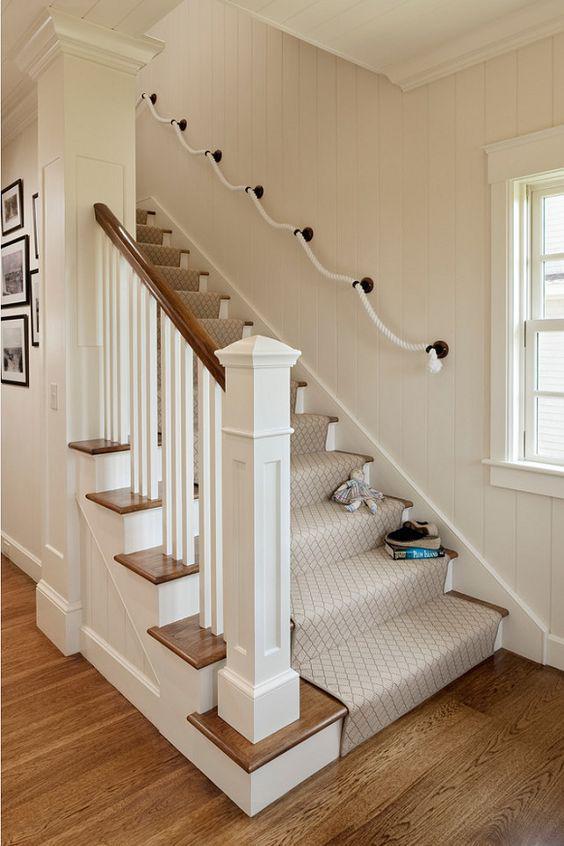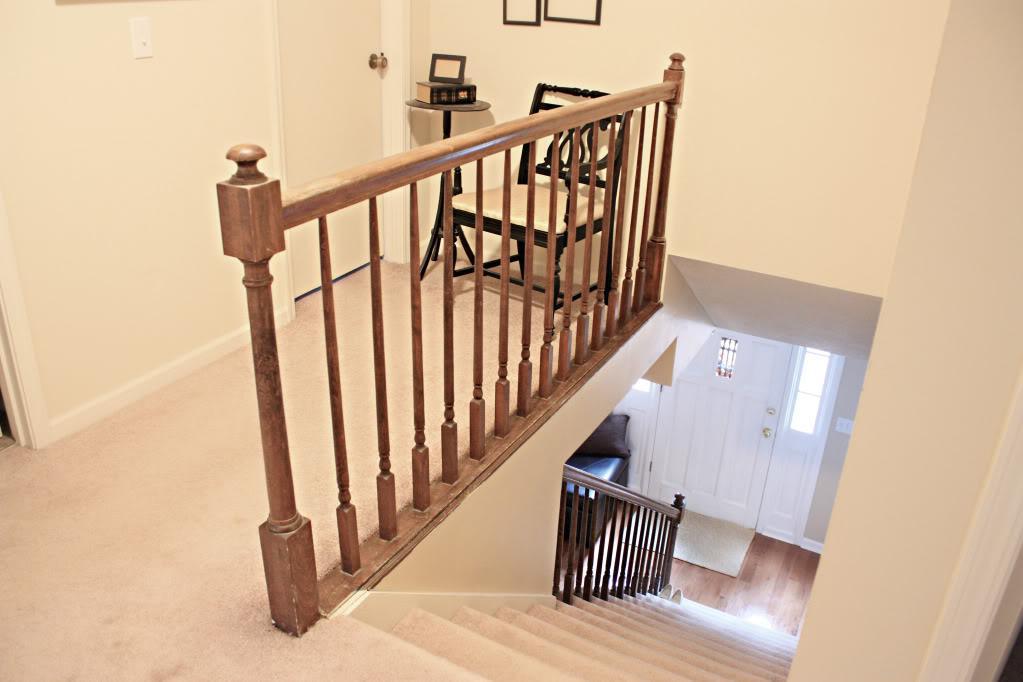The first image is the image on the left, the second image is the image on the right. Analyze the images presented: Is the assertion "One image taken on an upper floor shows a brown wood handrail with vertical 'spindles' that goes around at least one side of a stairwell." valid? Answer yes or no. Yes. The first image is the image on the left, the second image is the image on the right. Evaluate the accuracy of this statement regarding the images: "Part of the stairway railing is made of glass.". Is it true? Answer yes or no. No. 